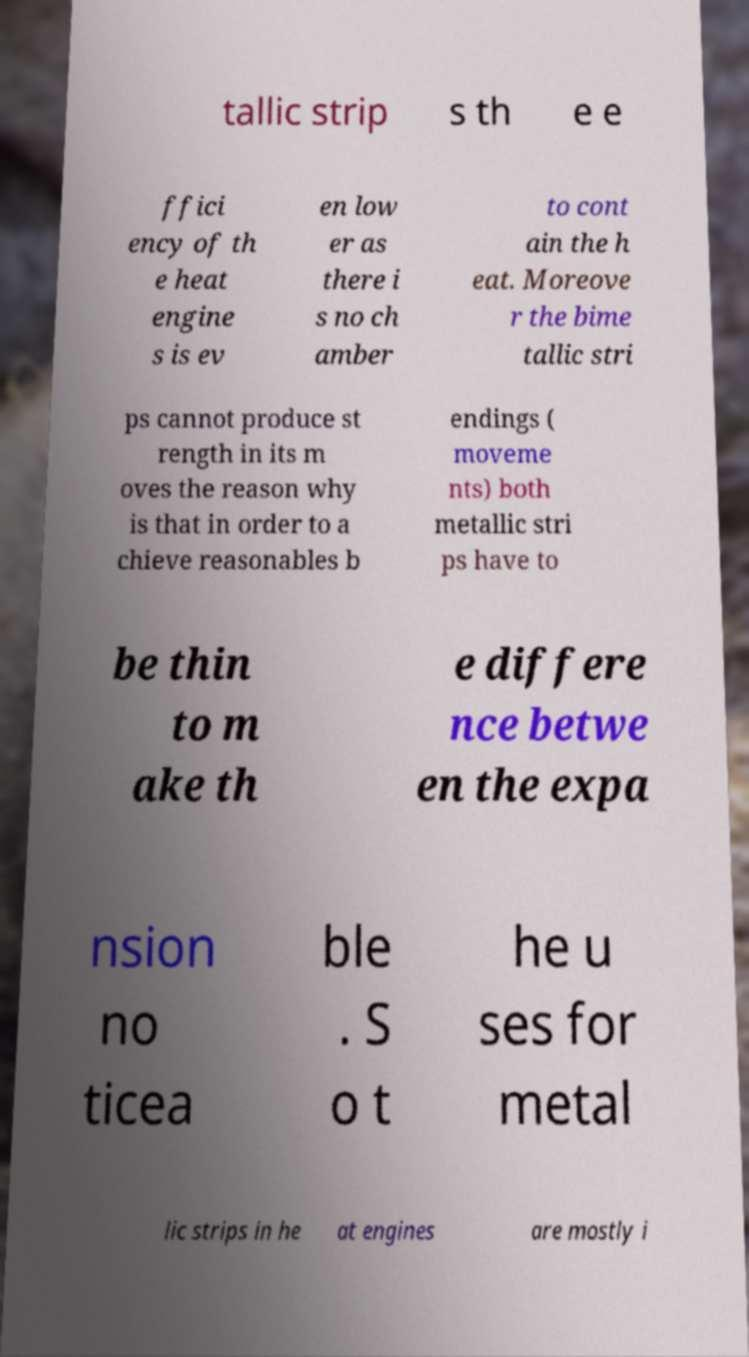Please identify and transcribe the text found in this image. tallic strip s th e e ffici ency of th e heat engine s is ev en low er as there i s no ch amber to cont ain the h eat. Moreove r the bime tallic stri ps cannot produce st rength in its m oves the reason why is that in order to a chieve reasonables b endings ( moveme nts) both metallic stri ps have to be thin to m ake th e differe nce betwe en the expa nsion no ticea ble . S o t he u ses for metal lic strips in he at engines are mostly i 